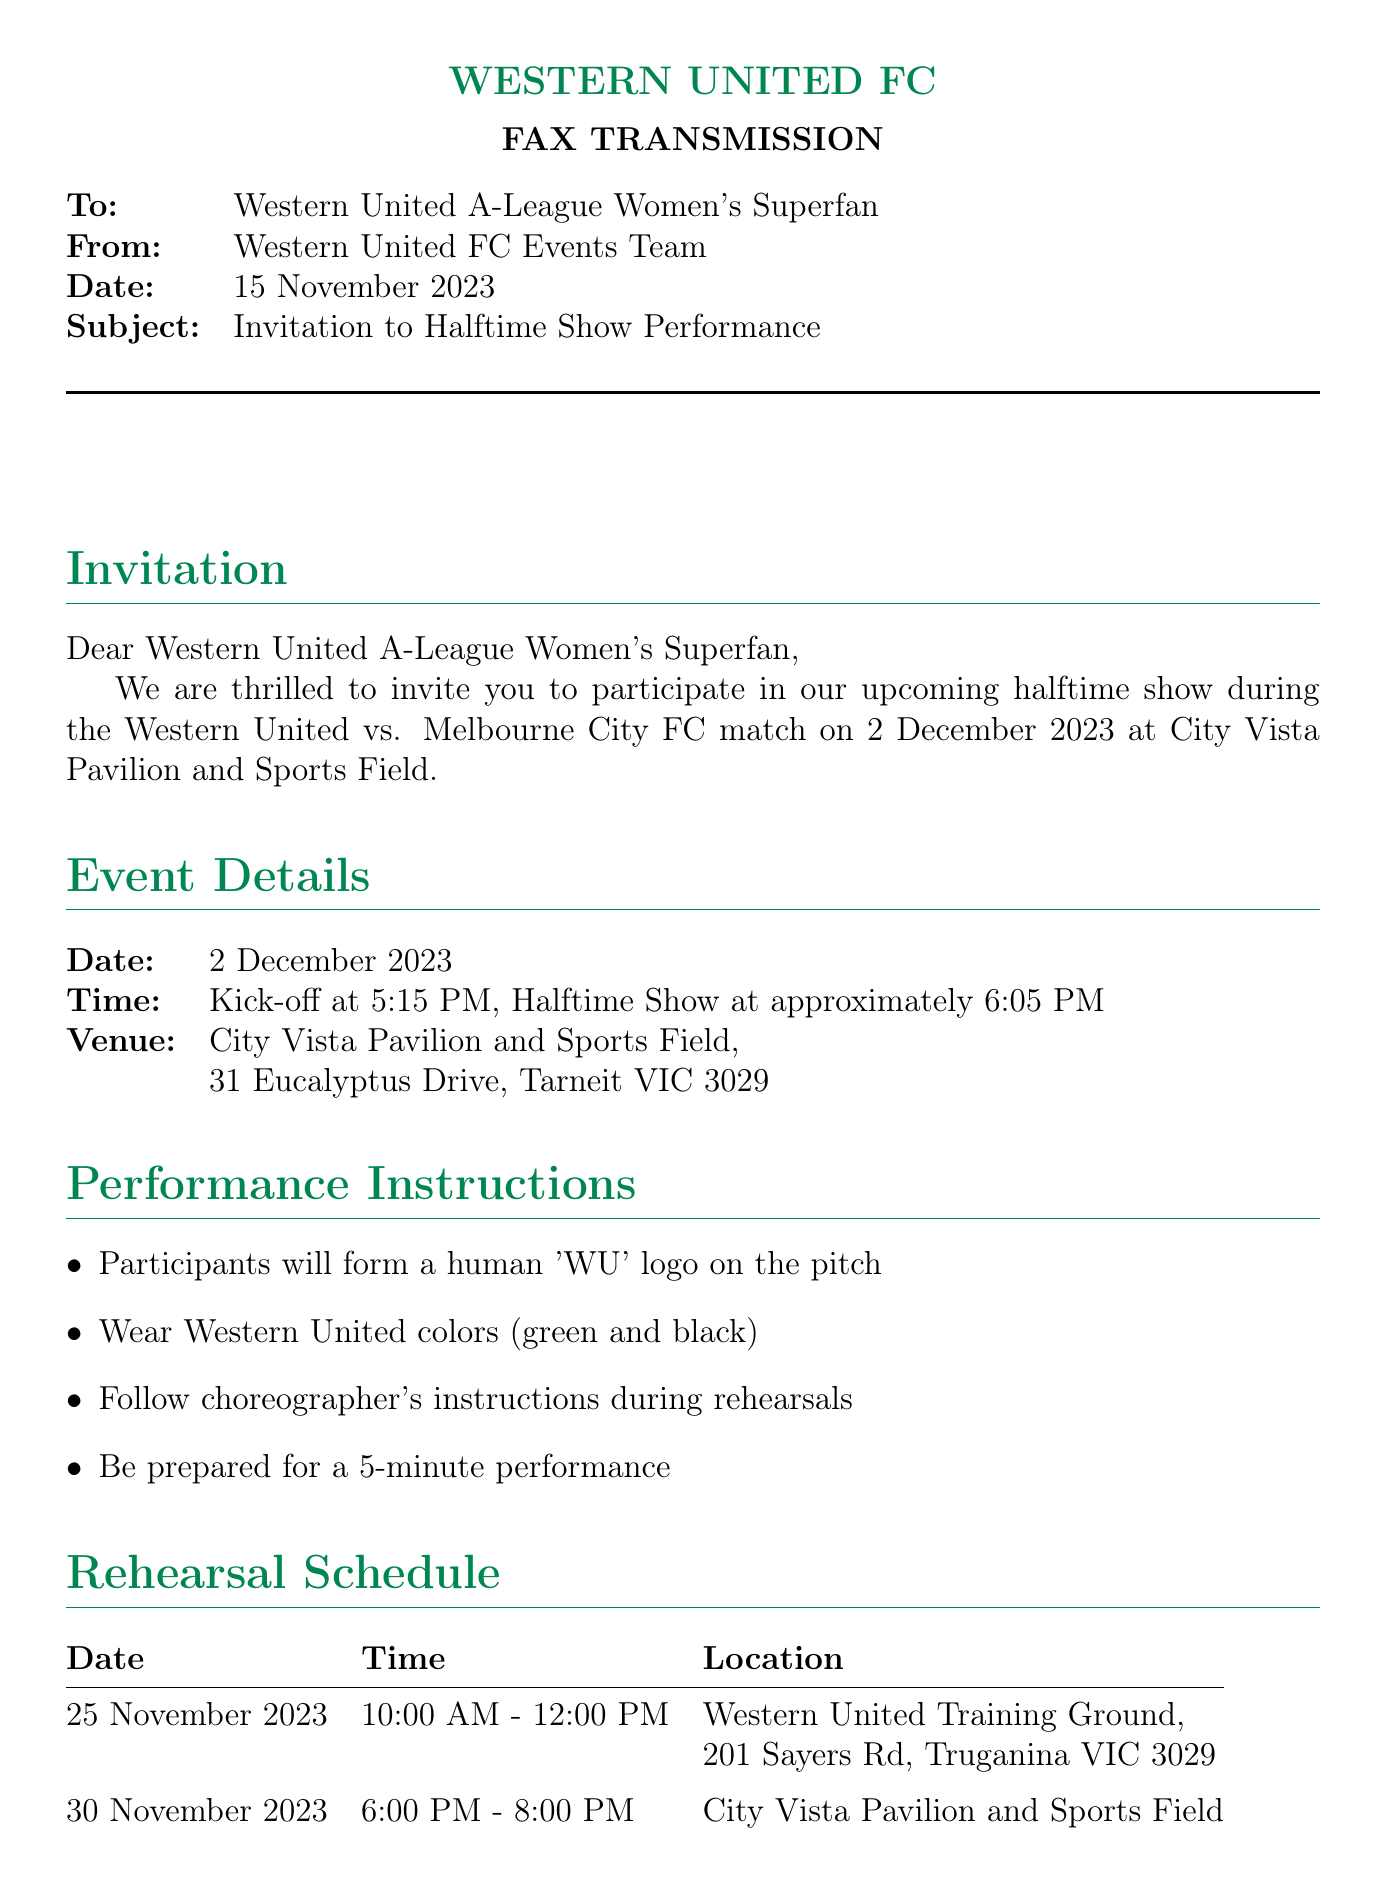What is the date of the halftime show? The halftime show is scheduled for 2 December 2023 according to the event details section.
Answer: 2 December 2023 What time does the halftime show start? The halftime show starts at approximately 6:05 PM, as stated in the event details.
Answer: 6:05 PM Where is the rehearsal on 30 November 2023? The rehearsal on 30 November 2023 will take place at City Vista Pavilion and Sports Field, according to the rehearsal schedule.
Answer: City Vista Pavilion and Sports Field Who should be contacted for RSVP? The fax mentions Sarah Thompson as the contact person for RSVP.
Answer: Sarah Thompson What is the performance duration? The performance is scheduled to last for 5 minutes, as listed in the performance instructions.
Answer: 5 minutes What color should participants wear? Participants are instructed to wear Western United colors, which are mentioned in the performance instructions.
Answer: Green and black When is the RSVP deadline? The RSVP deadline is specified as 22 November 2023 in the contact information section.
Answer: 22 November 2023 What is the address for the training ground? The address for the Western United Training Ground is provided as 201 Sayers Rd, Truganina VIC 3029 in the rehearsal schedule.
Answer: 201 Sayers Rd, Truganina VIC 3029 